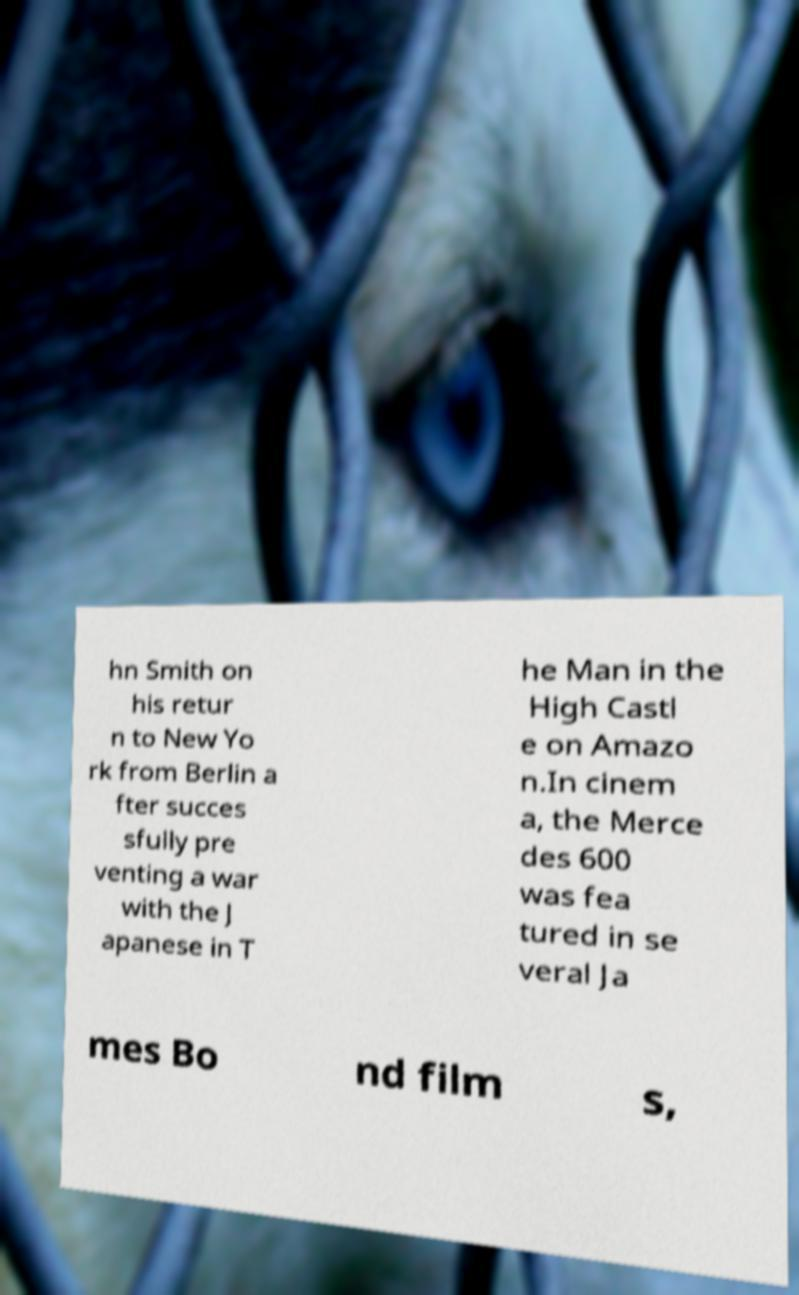There's text embedded in this image that I need extracted. Can you transcribe it verbatim? hn Smith on his retur n to New Yo rk from Berlin a fter succes sfully pre venting a war with the J apanese in T he Man in the High Castl e on Amazo n.In cinem a, the Merce des 600 was fea tured in se veral Ja mes Bo nd film s, 